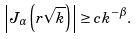Convert formula to latex. <formula><loc_0><loc_0><loc_500><loc_500>\left | J _ { \alpha } \left ( r \sqrt { k } \right ) \right | \geq c k ^ { - \beta } .</formula> 